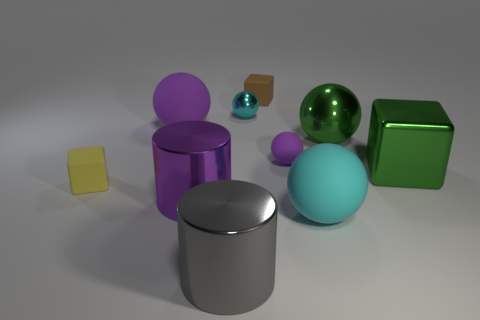Does the big block have the same color as the large metal ball?
Your answer should be very brief. Yes. There is a big object that is the same color as the large metal ball; what shape is it?
Provide a short and direct response. Cube. What number of cyan things are either big rubber spheres or matte objects?
Ensure brevity in your answer.  1. What is the shape of the tiny object in front of the purple rubber object on the right side of the big purple matte ball?
Your answer should be compact. Cube. What is the shape of the green shiny thing that is the same size as the green ball?
Ensure brevity in your answer.  Cube. Is there a ball of the same color as the large metal block?
Your answer should be compact. Yes. Are there the same number of big objects that are to the left of the large gray thing and cubes on the right side of the tiny cyan shiny thing?
Keep it short and to the point. Yes. Do the big cyan object and the big metallic object left of the big gray shiny object have the same shape?
Provide a short and direct response. No. Are there any large purple matte spheres behind the cyan matte thing?
Your answer should be compact. Yes. There is a cyan rubber ball; does it have the same size as the purple ball that is right of the brown block?
Provide a short and direct response. No. 